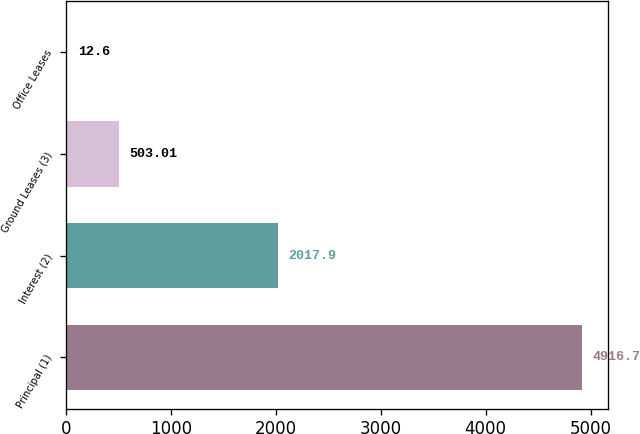Convert chart to OTSL. <chart><loc_0><loc_0><loc_500><loc_500><bar_chart><fcel>Principal (1)<fcel>Interest (2)<fcel>Ground Leases (3)<fcel>Office Leases<nl><fcel>4916.7<fcel>2017.9<fcel>503.01<fcel>12.6<nl></chart> 